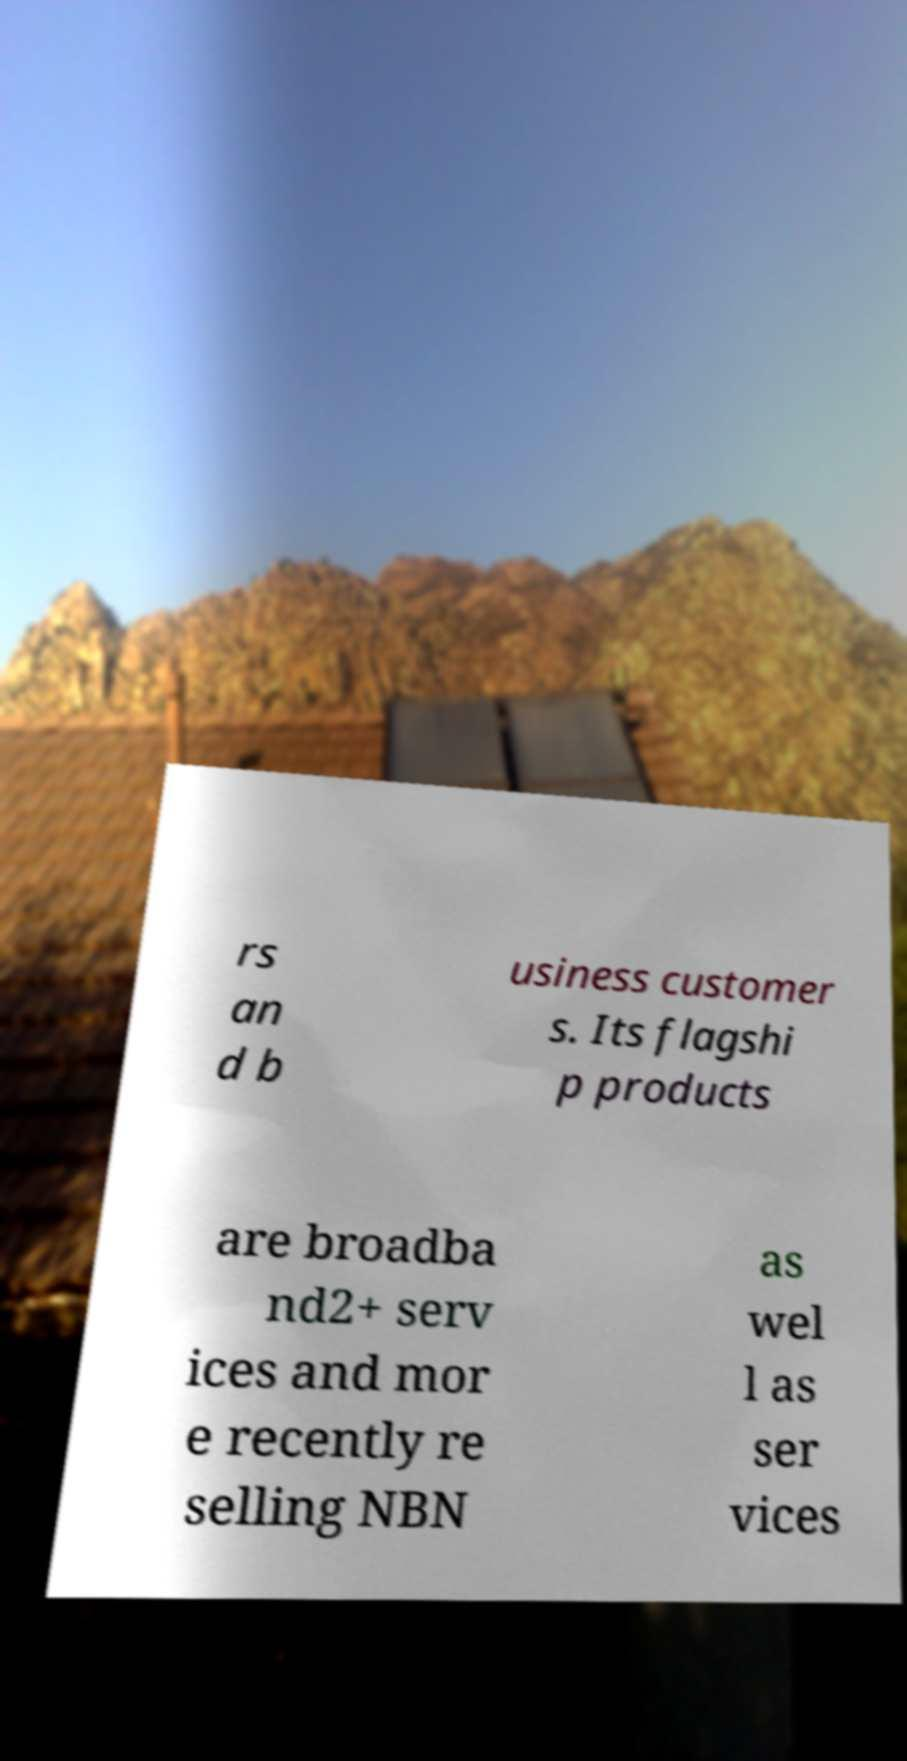Can you read and provide the text displayed in the image?This photo seems to have some interesting text. Can you extract and type it out for me? rs an d b usiness customer s. Its flagshi p products are broadba nd2+ serv ices and mor e recently re selling NBN as wel l as ser vices 